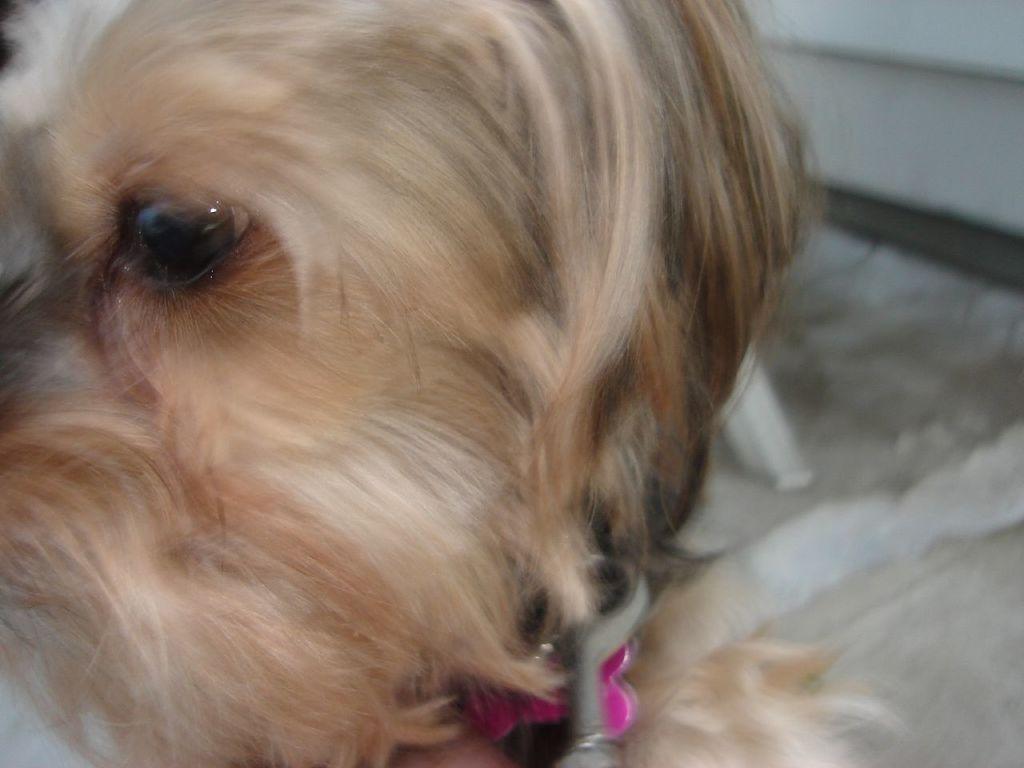Could you give a brief overview of what you see in this image? In this picture we can see a dog in the front, there is a blurry background. 